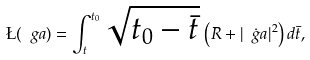<formula> <loc_0><loc_0><loc_500><loc_500>\L ( \ g a ) = \int _ { t } ^ { t _ { 0 } } \sqrt { t _ { 0 } - \bar { t } } \, \left ( R + | \dot { \ g a } | ^ { 2 } \right ) d \bar { t } ,</formula> 